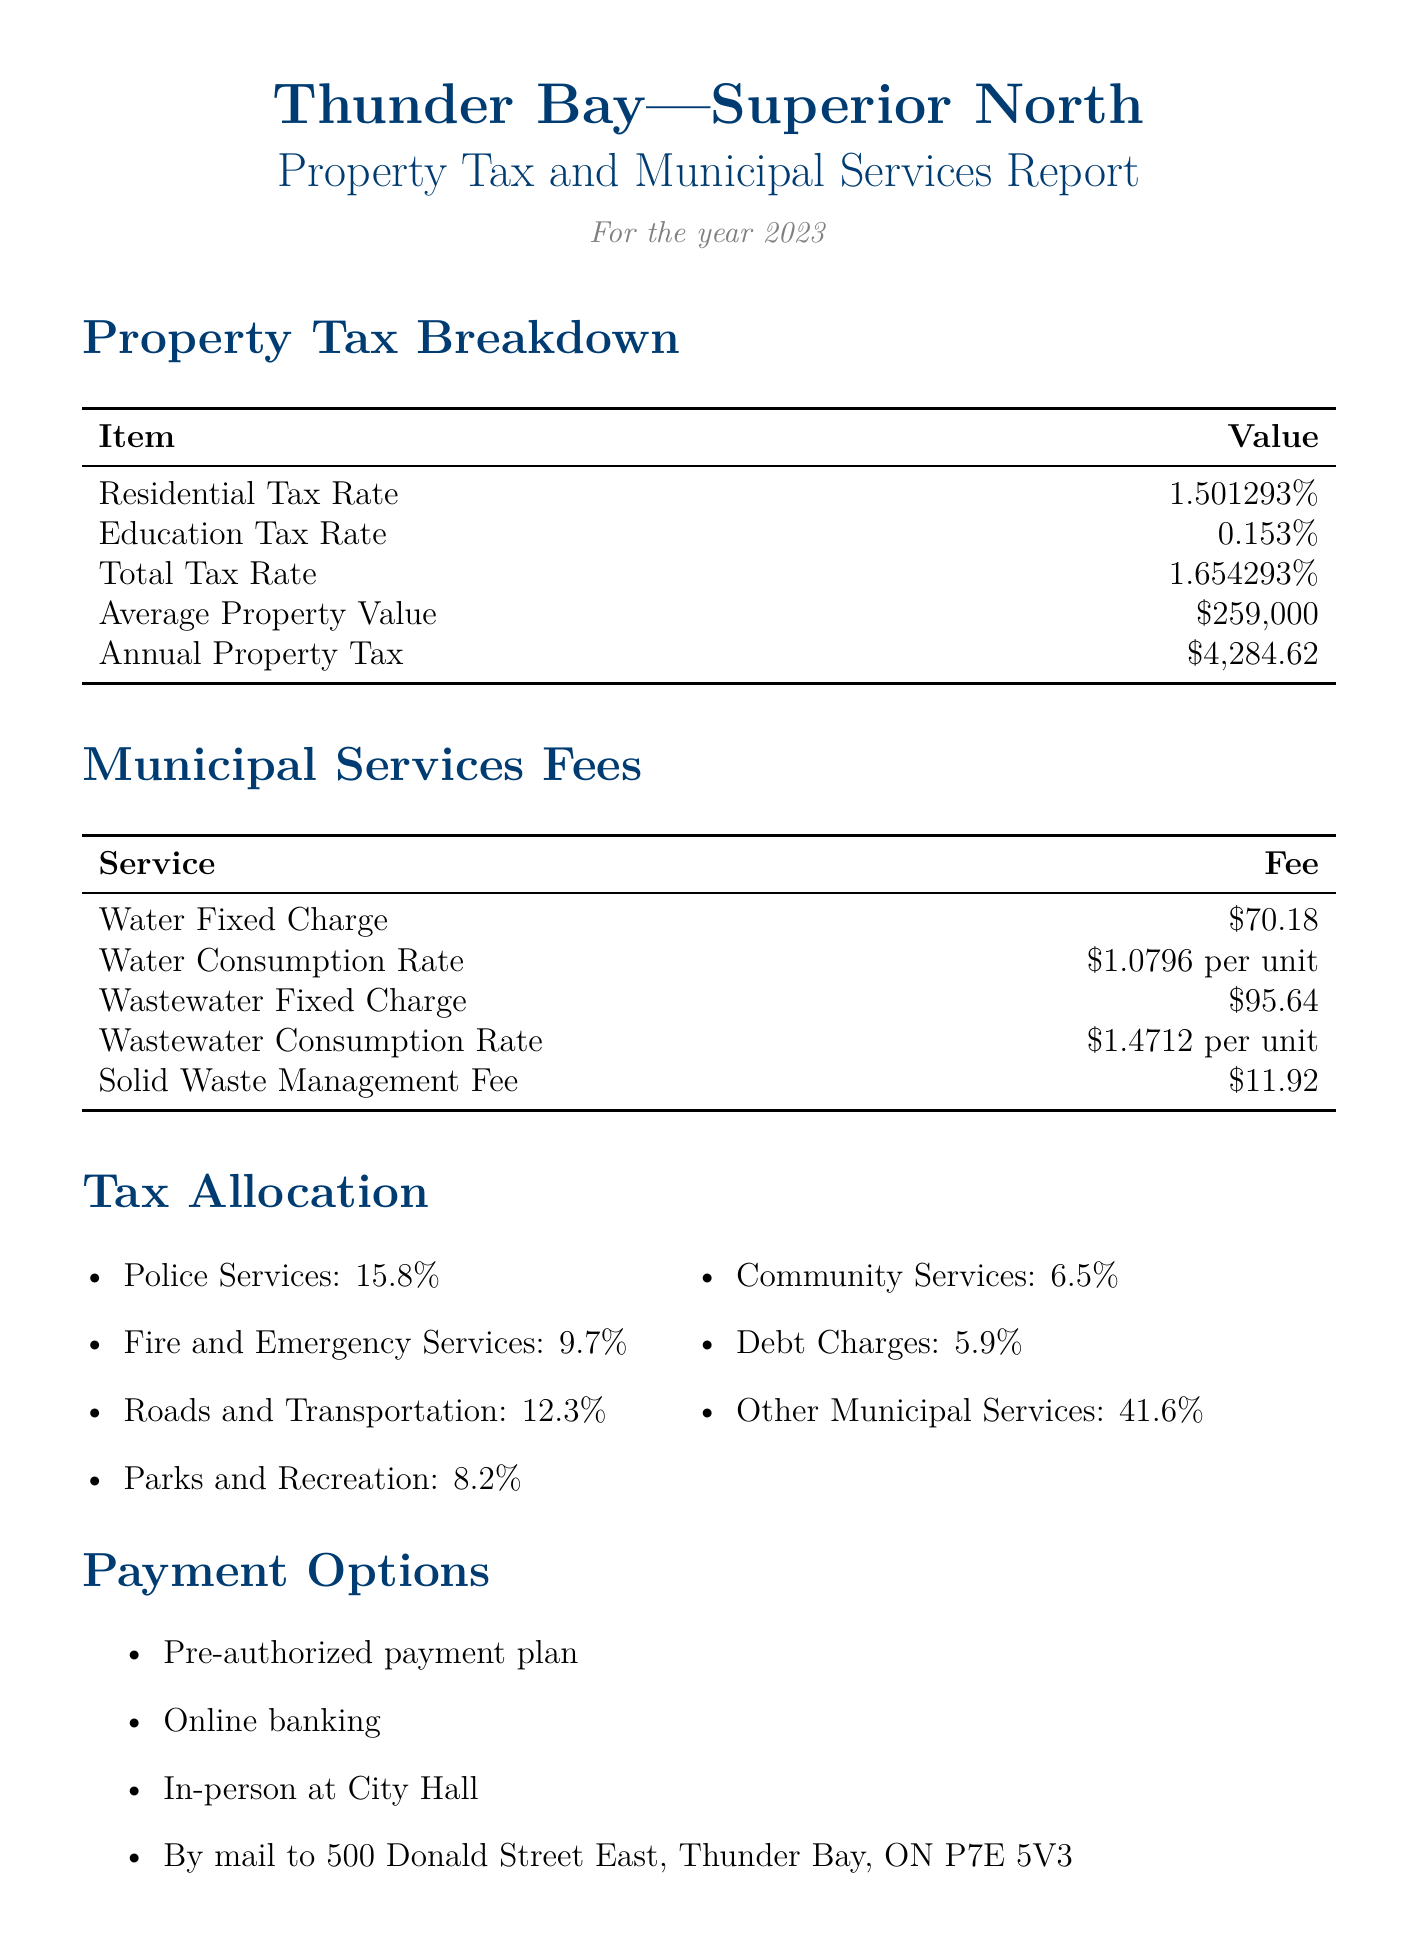What is the residential tax rate? The document specifies the residential tax rate as part of the property tax breakdown.
Answer: 1.501293% What is the annual property tax for an average property value? The report provides the annual property tax based on the average property value of $259,000.
Answer: $4,284.62 What is the wastewater fixed charge? The fee for wastewater services is listed in the municipal services fees section.
Answer: $95.64 Which service receives the highest tax allocation percentage? The tax allocation section lists percentages for various municipal services, with "Other Municipal Services" having the highest percentage.
Answer: 41.6% When is the first tax installment due? The important dates section outlines the tax installment due dates.
Answer: March 3, 2023 What is the assessment update year? The document highlights the year of the next assessment update in the important dates section.
Answer: 2024 How can residents pay their property taxes? The payment options section specifies multiple methods available for tax payment.
Answer: Pre-authorized payment plan, Online banking, In-person at City Hall, By mail What percentage of the tax allocation is dedicated to police services? The document lists police services' allocation percentage under the tax allocation section.
Answer: 15.8% What is the phone number for the Revenue Division? The contact information includes the Revenue Division's phone number for inquiries.
Answer: 807-625-2255 